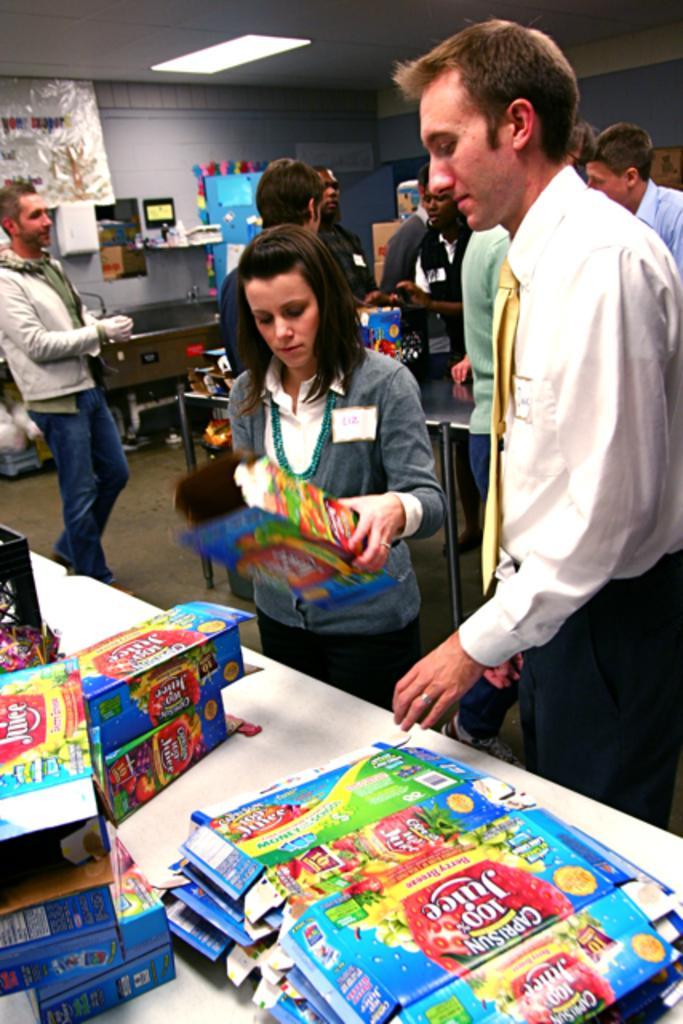Can you describe this image briefly? In this picture there are group of people standing. In the foreground there is a woman standing and holding the box and there are boxes on the table and there is text on the boxes. At the back there is a table and there are cardboard boxes and there are objects on the wall. At the top there is a light. At the bottom there is a mat. 